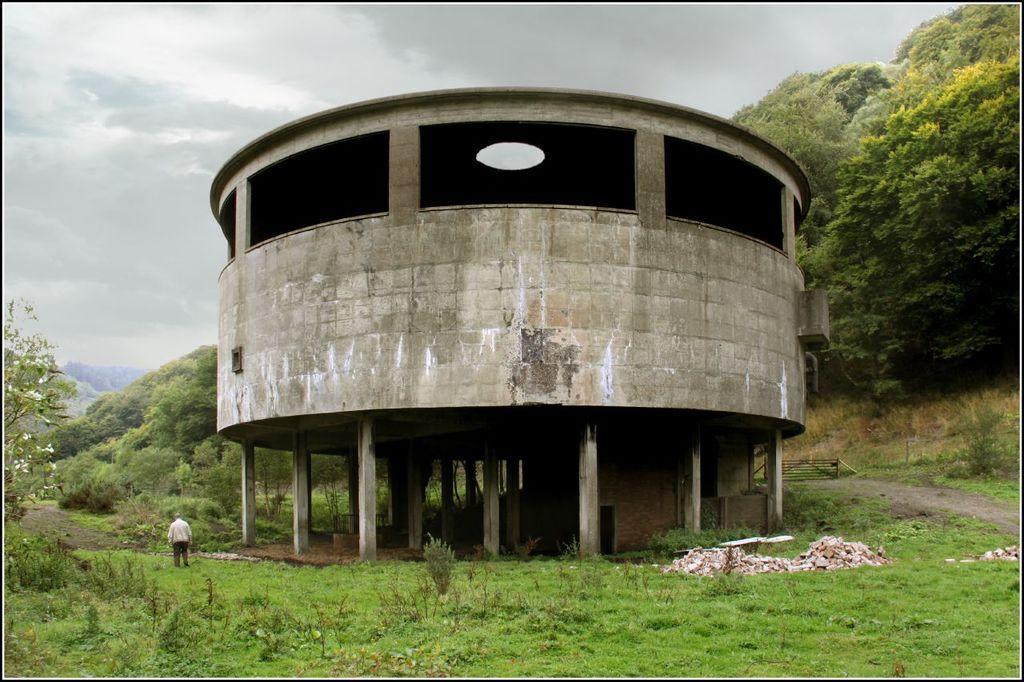Describe this image in one or two sentences. In the center of the image, we can see a fort and there is a person standing. In the background, there are trees and at the bottom, there are plants and stones are on the ground. 